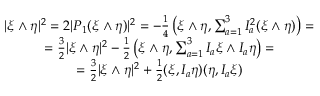<formula> <loc_0><loc_0><loc_500><loc_500>\begin{array} { c } { { | \xi \wedge \eta | ^ { 2 } = 2 | P _ { 1 } ( \xi \wedge \eta ) | ^ { 2 } = - { \frac { 1 } { 4 } } \left ( \xi \wedge \eta , \sum _ { a = 1 } ^ { 3 } I _ { a } ^ { 2 } ( \xi \wedge \eta ) \right ) = } } \\ { { = { \frac { 3 } { 2 } } | \xi \wedge \eta | ^ { 2 } - { \frac { 1 } { 2 } } \left ( \xi \wedge \eta , \sum _ { a = 1 } ^ { 3 } I _ { a } \xi \wedge I _ { a } \eta \right ) = } } \\ { { = { \frac { 3 } { 2 } } | \xi \wedge \eta | ^ { 2 } + { \frac { 1 } { 2 } } ( \xi , I _ { a } \eta ) ( \eta , I _ { a } \xi ) } } \end{array}</formula> 